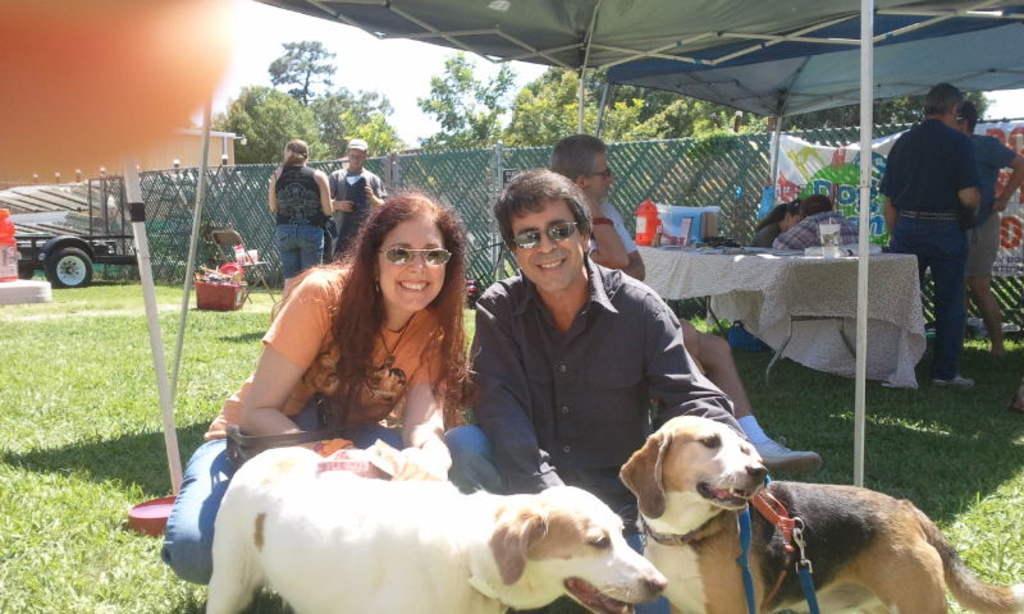Describe this image in one or two sentences. Here there are 2 dogs,2 persons. Behind them there are few people standing. And there is a table,fence,tree and a sky and a vehicle. 